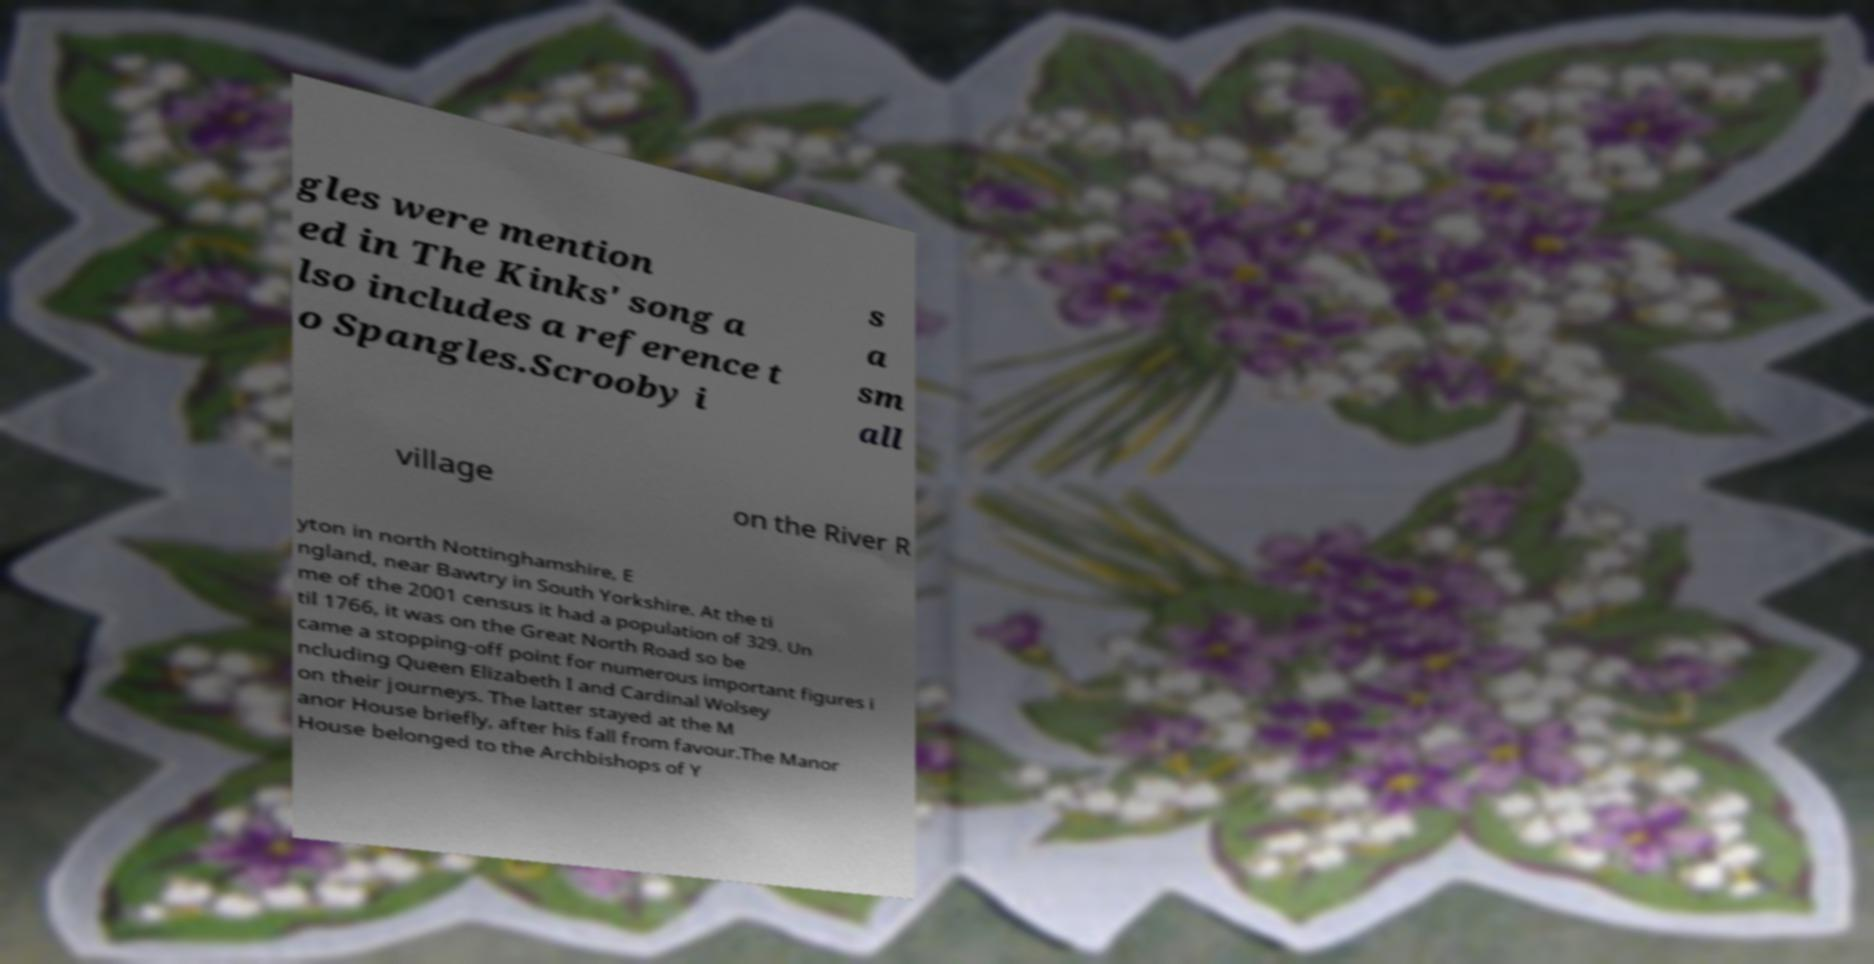Could you extract and type out the text from this image? gles were mention ed in The Kinks' song a lso includes a reference t o Spangles.Scrooby i s a sm all village on the River R yton in north Nottinghamshire, E ngland, near Bawtry in South Yorkshire. At the ti me of the 2001 census it had a population of 329. Un til 1766, it was on the Great North Road so be came a stopping-off point for numerous important figures i ncluding Queen Elizabeth I and Cardinal Wolsey on their journeys. The latter stayed at the M anor House briefly, after his fall from favour.The Manor House belonged to the Archbishops of Y 